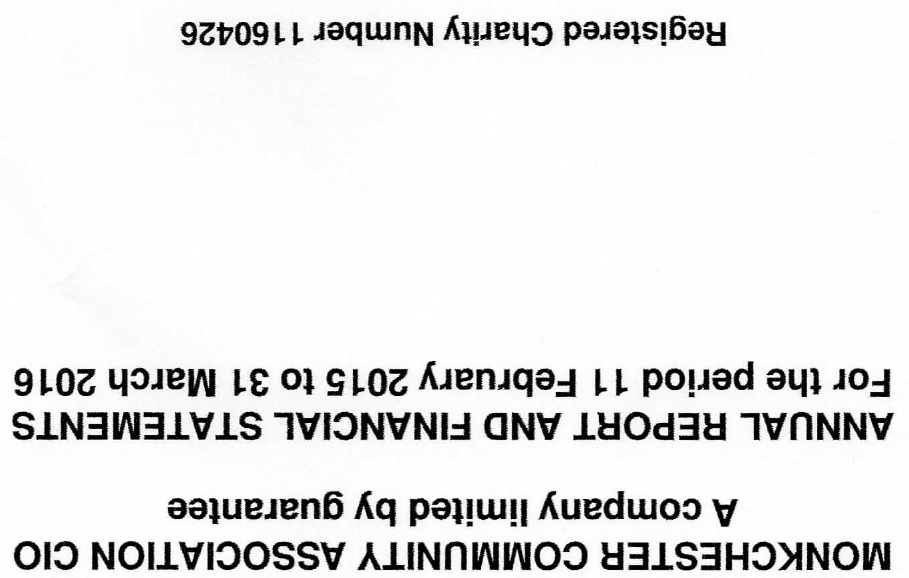What is the value for the address__street_line?
Answer the question using a single word or phrase. 204 MONKCHESTER ROAD 